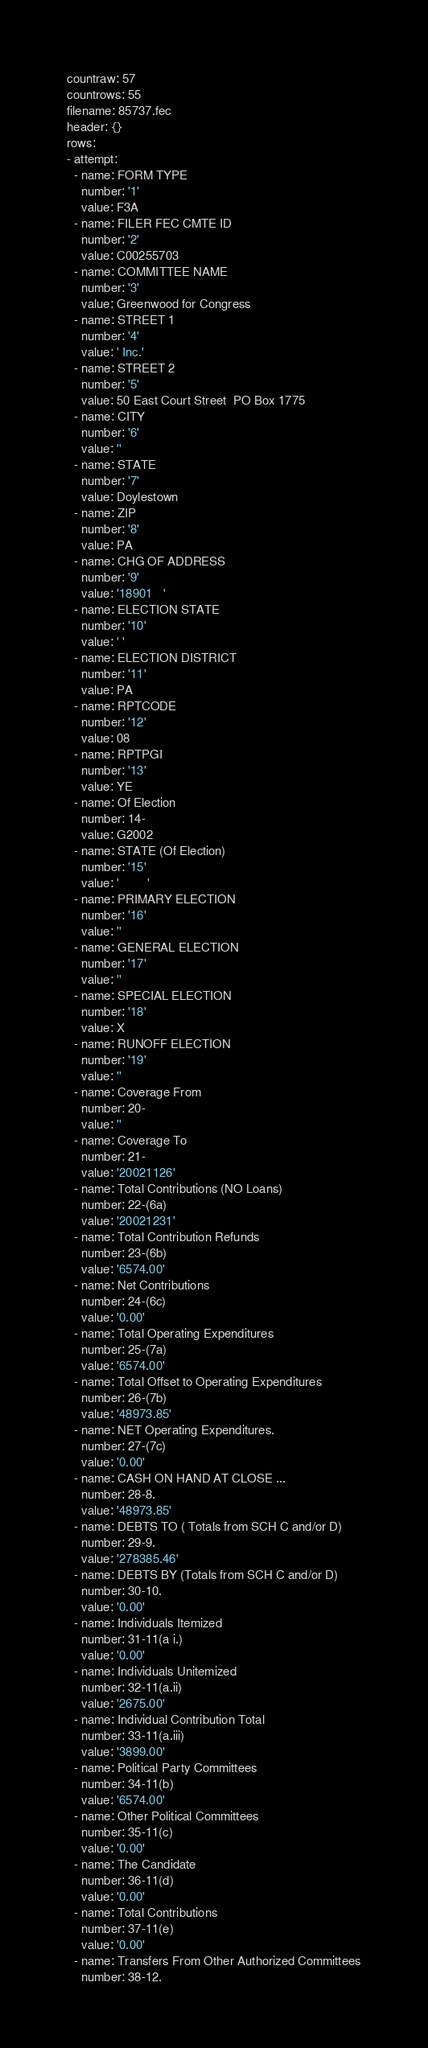Convert code to text. <code><loc_0><loc_0><loc_500><loc_500><_YAML_>countraw: 57
countrows: 55
filename: 85737.fec
header: {}
rows:
- attempt:
  - name: FORM TYPE
    number: '1'
    value: F3A
  - name: FILER FEC CMTE ID
    number: '2'
    value: C00255703
  - name: COMMITTEE NAME
    number: '3'
    value: Greenwood for Congress
  - name: STREET 1
    number: '4'
    value: ' Inc.'
  - name: STREET 2
    number: '5'
    value: 50 East Court Street  PO Box 1775
  - name: CITY
    number: '6'
    value: ''
  - name: STATE
    number: '7'
    value: Doylestown
  - name: ZIP
    number: '8'
    value: PA
  - name: CHG OF ADDRESS
    number: '9'
    value: '18901   '
  - name: ELECTION STATE
    number: '10'
    value: ' '
  - name: ELECTION DISTRICT
    number: '11'
    value: PA
  - name: RPTCODE
    number: '12'
    value: 08
  - name: RPTPGI
    number: '13'
    value: YE
  - name: Of Election
    number: 14-
    value: G2002
  - name: STATE (Of Election)
    number: '15'
    value: '        '
  - name: PRIMARY ELECTION
    number: '16'
    value: ''
  - name: GENERAL ELECTION
    number: '17'
    value: ''
  - name: SPECIAL ELECTION
    number: '18'
    value: X
  - name: RUNOFF ELECTION
    number: '19'
    value: ''
  - name: Coverage From
    number: 20-
    value: ''
  - name: Coverage To
    number: 21-
    value: '20021126'
  - name: Total Contributions (NO Loans)
    number: 22-(6a)
    value: '20021231'
  - name: Total Contribution Refunds
    number: 23-(6b)
    value: '6574.00'
  - name: Net Contributions
    number: 24-(6c)
    value: '0.00'
  - name: Total Operating Expenditures
    number: 25-(7a)
    value: '6574.00'
  - name: Total Offset to Operating Expenditures
    number: 26-(7b)
    value: '48973.85'
  - name: NET Operating Expenditures.
    number: 27-(7c)
    value: '0.00'
  - name: CASH ON HAND AT CLOSE ...
    number: 28-8.
    value: '48973.85'
  - name: DEBTS TO ( Totals from SCH C and/or D)
    number: 29-9.
    value: '278385.46'
  - name: DEBTS BY (Totals from SCH C and/or D)
    number: 30-10.
    value: '0.00'
  - name: Individuals Itemized
    number: 31-11(a i.)
    value: '0.00'
  - name: Individuals Unitemized
    number: 32-11(a.ii)
    value: '2675.00'
  - name: Individual Contribution Total
    number: 33-11(a.iii)
    value: '3899.00'
  - name: Political Party Committees
    number: 34-11(b)
    value: '6574.00'
  - name: Other Political Committees
    number: 35-11(c)
    value: '0.00'
  - name: The Candidate
    number: 36-11(d)
    value: '0.00'
  - name: Total Contributions
    number: 37-11(e)
    value: '0.00'
  - name: Transfers From Other Authorized Committees
    number: 38-12.</code> 